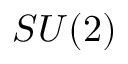<formula> <loc_0><loc_0><loc_500><loc_500>S U ( 2 )</formula> 